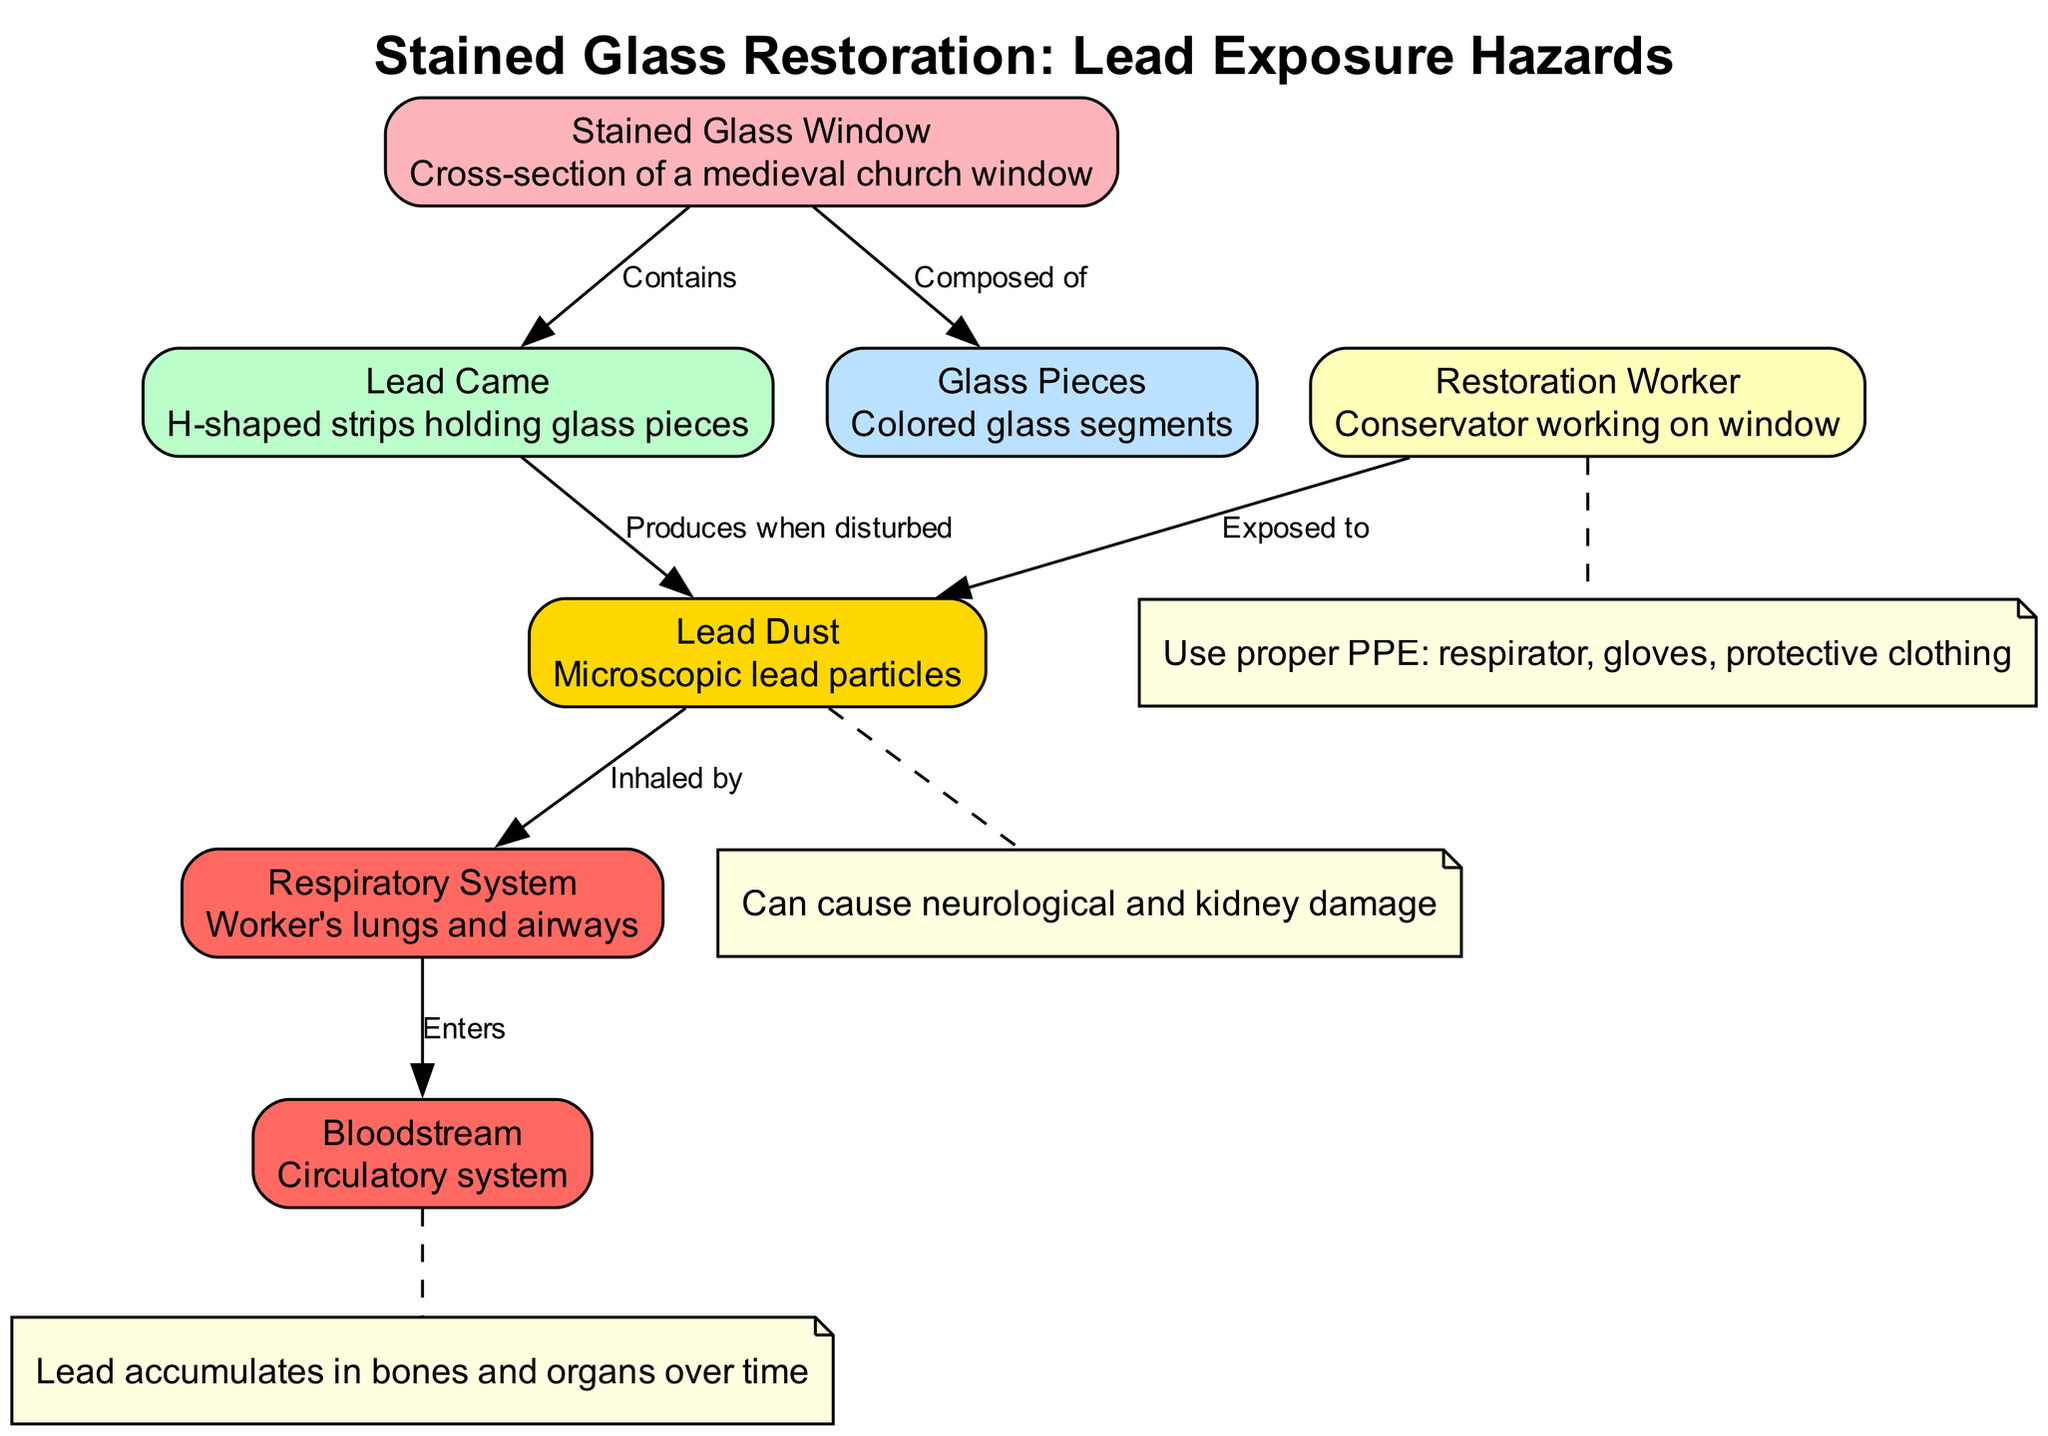What is the node label for node 2? The node label for node 2 is "Lead Came," which describes the H-shaped strips holding glass pieces.
Answer: Lead Came How many nodes are present in the diagram? The diagram contains a total of 7 nodes, which can be counted from the provided nodes list.
Answer: 7 What are the two components that the Stained Glass Window is composed of? The Stained Glass Window is composed of Glass Pieces and contains Lead Came, as indicated in the edges connected to it.
Answer: Glass Pieces and Lead Came Which system is affected by inhaled lead dust? The Respiratory System is affected by the inhalation of lead dust, as specified in the edge connecting Lead Dust to the Respiratory System.
Answer: Respiratory System What material does the lead came produce when disturbed? The lead came produces Lead Dust when disturbed, as shown in the edge that connects the Lead Came to Lead Dust.
Answer: Lead Dust What is the potential consequence of lead exposure according to the annotation? The annotation indicates that lead exposure can cause neurological and kidney damage, summarizing the health hazards linked to lead.
Answer: Neurological and kidney damage How does lead enter the bloodstream as per the diagram? Lead enters the bloodstream after being inhaled by the respiratory system, establishing a flow from Lead Dust to the Respiratory System and then to the Bloodstream.
Answer: Enters through the Respiratory System What should restoration workers use to protect themselves? According to the annotation related to the restoration worker, they should use proper Personal Protective Equipment (PPE), including a respirator, gloves, and protective clothing.
Answer: Proper PPE How does lead accumulate in the body? The annotation specifies that lead accumulates in bones and organs over time, highlighting the long-term effects of lead exposure.
Answer: In bones and organs over time 